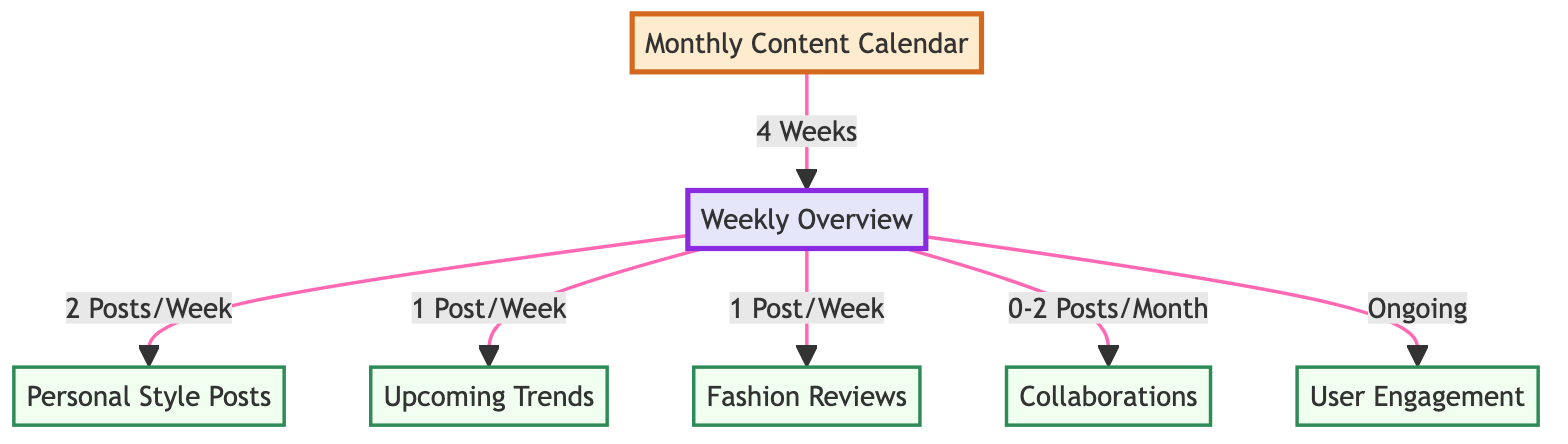How many posts are scheduled per week for Personal Style? The diagram shows an arrow leading from the Weekly Overview node to Personal Style Posts, with a label indicating "2 Posts/Week." This directly provides the information on the frequency for this content type.
Answer: 2 Posts/Week What is the total number of node types in the diagram? By counting each unique node, we find there are six types of content nodes (Personal Style Posts, Upcoming Trends, Fashion Reviews, Collaborations, User Engagement, and the Monthly Content Calendar). Including the Weekly Overview, the total is seven unique nodes.
Answer: 7 How many weeks does the Monthly Content Calendar cover? The diagram shows a link between the Monthly Content Calendar and the Weekly Overview with a label "4 Weeks," indicating the total coverage of the calendar.
Answer: 4 Weeks What type of content has an ongoing posting frequency? In the Weekly Overview, it is noted that User Engagement has the label "Ongoing," meaning it doesn't have a specified post frequency like the other types of content.
Answer: Ongoing How many different types of posts are made each month? By analyzing the diagram, we see that the Monthly Content Calendar encompasses a total of four different post types which are Personal Style, Upcoming Trends, Fashion Reviews, and Collaborations. Therefore, we count these as distinctly different types of posts.
Answer: 4 Types of Posts What is the post frequency for Collaborations? The diagram specifies the link from the Weekly Overview to the Collaborations node, labeled "0-2 Posts/Month." This indicates the variability in the frequency of this content type.
Answer: 0-2 Posts/Month How many posts are planned for Upcoming Trends? According to the diagram, the Weekly Overview connects with Upcoming Trends with the notation of "1 Post/Week," providing clear information on the frequency for this content.
Answer: 1 Post/Week What is the purpose of the Monthly Content Calendar node? The Monthly Content Calendar node serves as the primary organizing node for all subsequent content planning laid out in the diagram. This role is indicated by being the starting point of the flow.
Answer: Organizing Content How many nodes are related to User Engagement? User Engagement is represented as a single node in the diagram, implying no multiple connections or types specifically designated to it. Thus, it is a standalone element in the content planning structure.
Answer: 1 Node 